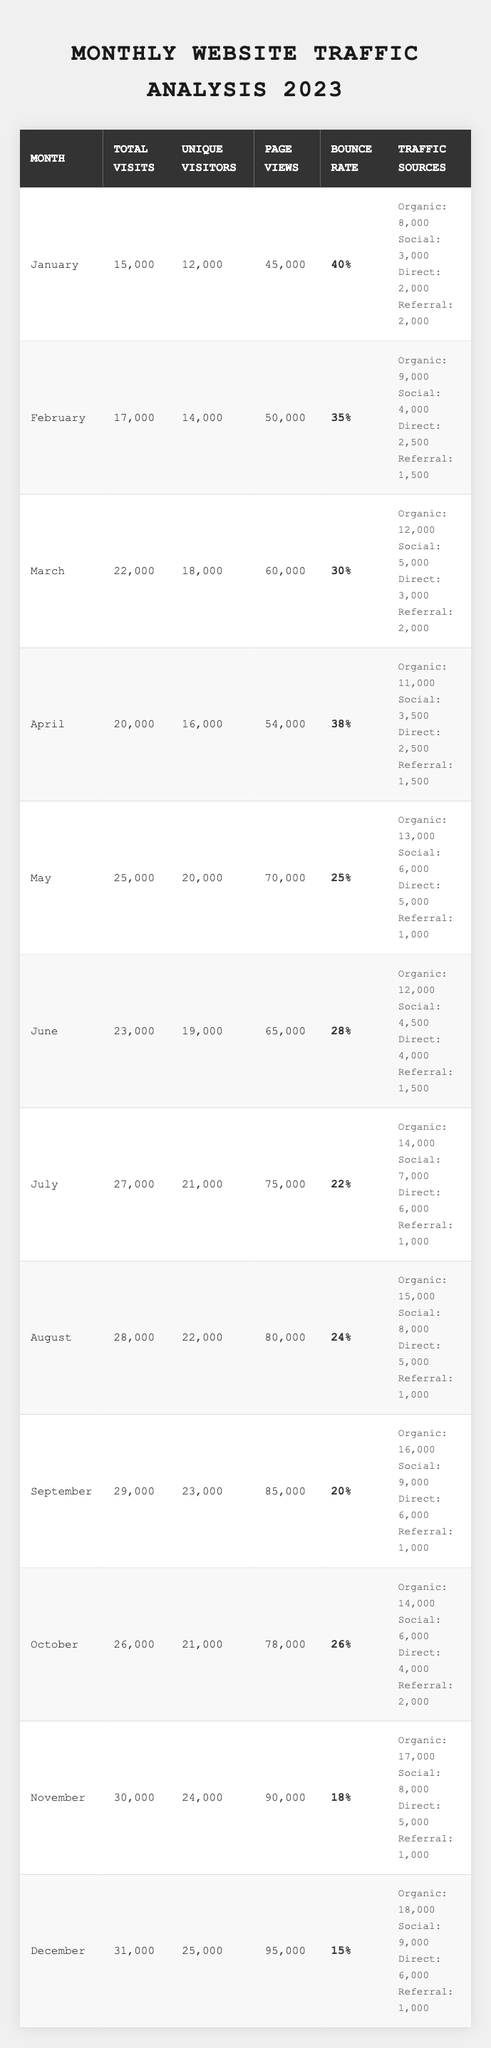What was the total number of visits in August? In August, the table shows a total of 28,000 visits.
Answer: 28,000 Which month had the highest bounce rate? The month with the highest bounce rate was January, at 40%.
Answer: January What is the average number of unique visitors from January to March? The unique visitors for January, February, and March are 12,000, 14,000, and 18,000, respectively. The sum is 12,000 + 14,000 + 18,000 = 44,000, and the average is 44,000 / 3 ≈ 14,667.
Answer: 14,667 Did September have a lower bounce rate than May? September had a bounce rate of 20%, while May had a bounce rate of 25%. Since 20% is less than 25%, the statement is true.
Answer: Yes What is the total number of page views from April to June? April had 54,000 page views, May had 70,000, and June had 65,000. The total is 54,000 + 70,000 + 65,000 = 189,000.
Answer: 189,000 Which month had the most traffic from organic search? July had the most traffic from organic search with 14,000 visits.
Answer: July What is the median number of total visits from January to December? The total visits for each month were: 15,000, 17,000, 22,000, 20,000, 25,000, 23,000, 27,000, 28,000, 29,000, 26,000, 30,000, and 31,000. When arranged in order, the values are 15,000, 17,000, 20,000, 22,000, 23,000, 25,000, 26,000, 27,000, 28,000, 29,000, 30,000, and 31,000. There are 12 values, so the median is (25,000 + 26,000) / 2 = 25,500.
Answer: 25,500 In which month did unique visitors reach 24,000? Unique visitors reached 24,000 in November.
Answer: November What was the difference in total visits between September and January? September had 29,000 total visits and January had 15,000 visits. The difference is 29,000 - 15,000 = 14,000.
Answer: 14,000 Which traffic source had the least visits in May? The referral traffic source had the least visits in May, with 1,000 visits.
Answer: 1,000 What is the total percentage of bounce rates from July to December? The bounce rates from July (22%), August (24%), September (20%), October (26%), November (18%), and December (15%) sum to 22 + 24 + 20 + 26 + 18 + 15 = 125%. The average bounce rate is then 125% / 6 ≈ 20.83%.
Answer: 20.83% 